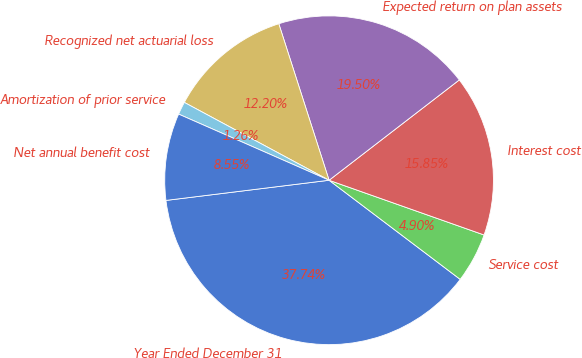<chart> <loc_0><loc_0><loc_500><loc_500><pie_chart><fcel>Year Ended December 31<fcel>Service cost<fcel>Interest cost<fcel>Expected return on plan assets<fcel>Recognized net actuarial loss<fcel>Amortization of prior service<fcel>Net annual benefit cost<nl><fcel>37.74%<fcel>4.9%<fcel>15.85%<fcel>19.5%<fcel>12.2%<fcel>1.26%<fcel>8.55%<nl></chart> 